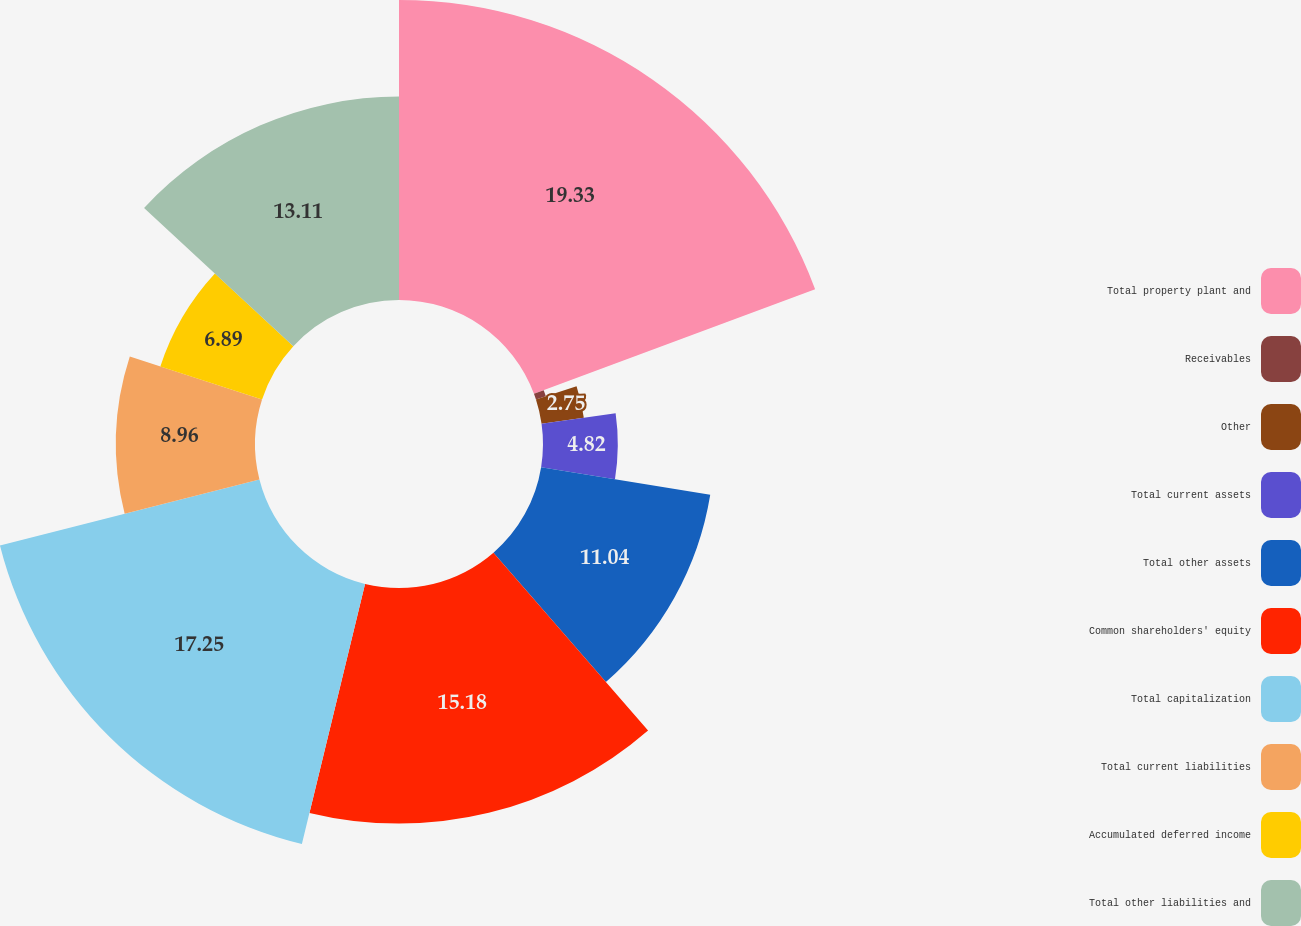Convert chart. <chart><loc_0><loc_0><loc_500><loc_500><pie_chart><fcel>Total property plant and<fcel>Receivables<fcel>Other<fcel>Total current assets<fcel>Total other assets<fcel>Common shareholders' equity<fcel>Total capitalization<fcel>Total current liabilities<fcel>Accumulated deferred income<fcel>Total other liabilities and<nl><fcel>19.33%<fcel>0.67%<fcel>2.75%<fcel>4.82%<fcel>11.04%<fcel>15.18%<fcel>17.25%<fcel>8.96%<fcel>6.89%<fcel>13.11%<nl></chart> 